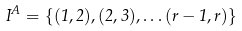Convert formula to latex. <formula><loc_0><loc_0><loc_500><loc_500>I ^ { A } = \{ ( 1 , 2 ) , ( 2 , 3 ) , \dots ( r - 1 , r ) \}</formula> 